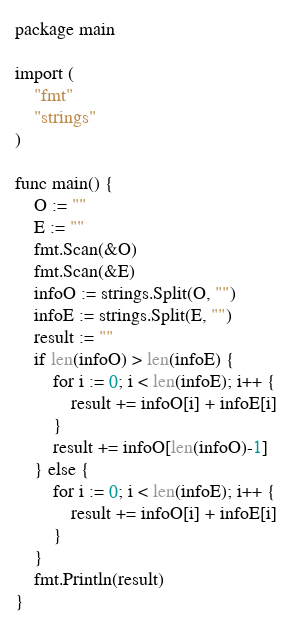Convert code to text. <code><loc_0><loc_0><loc_500><loc_500><_Go_>package main

import (
	"fmt"
	"strings"
)

func main() {
	O := ""
	E := ""
	fmt.Scan(&O)
	fmt.Scan(&E)
	infoO := strings.Split(O, "")
	infoE := strings.Split(E, "")
	result := ""
	if len(infoO) > len(infoE) {
		for i := 0; i < len(infoE); i++ {
			result += infoO[i] + infoE[i]
		}
		result += infoO[len(infoO)-1]
	} else {
		for i := 0; i < len(infoE); i++ {
			result += infoO[i] + infoE[i]
		}
	}
	fmt.Println(result)
}</code> 